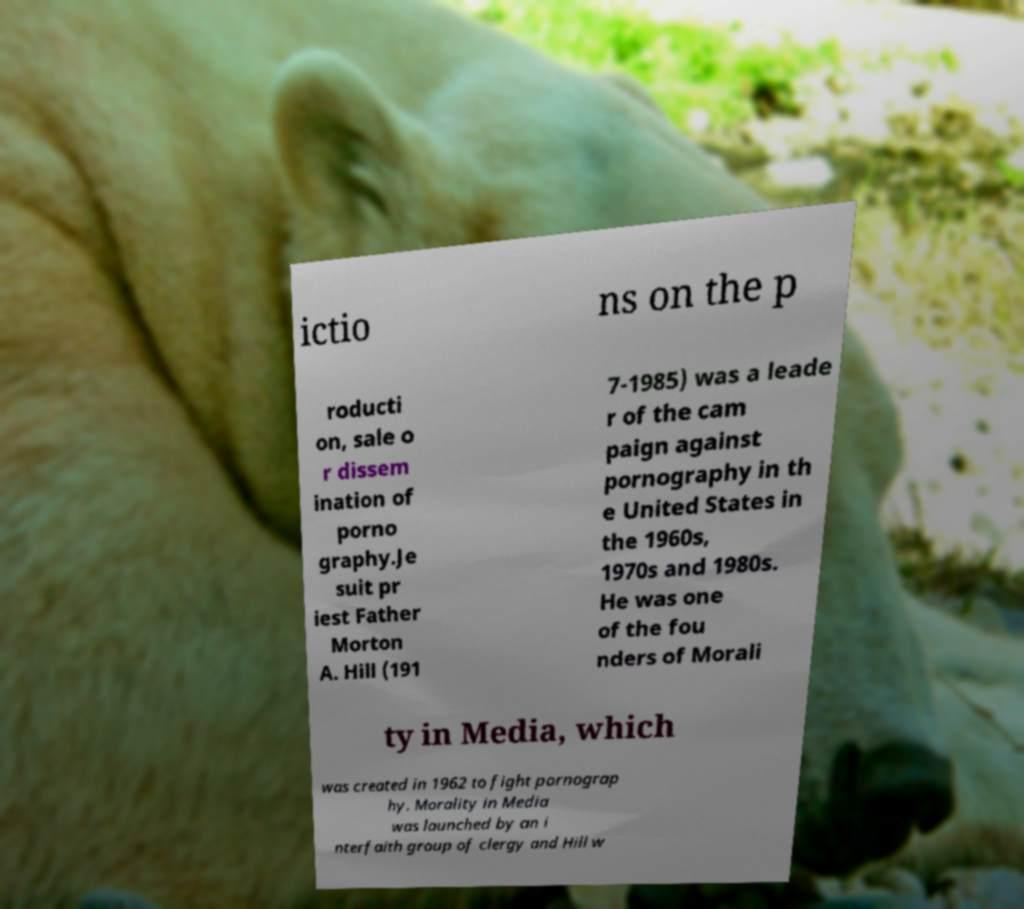What messages or text are displayed in this image? I need them in a readable, typed format. ictio ns on the p roducti on, sale o r dissem ination of porno graphy.Je suit pr iest Father Morton A. Hill (191 7-1985) was a leade r of the cam paign against pornography in th e United States in the 1960s, 1970s and 1980s. He was one of the fou nders of Morali ty in Media, which was created in 1962 to fight pornograp hy. Morality in Media was launched by an i nterfaith group of clergy and Hill w 